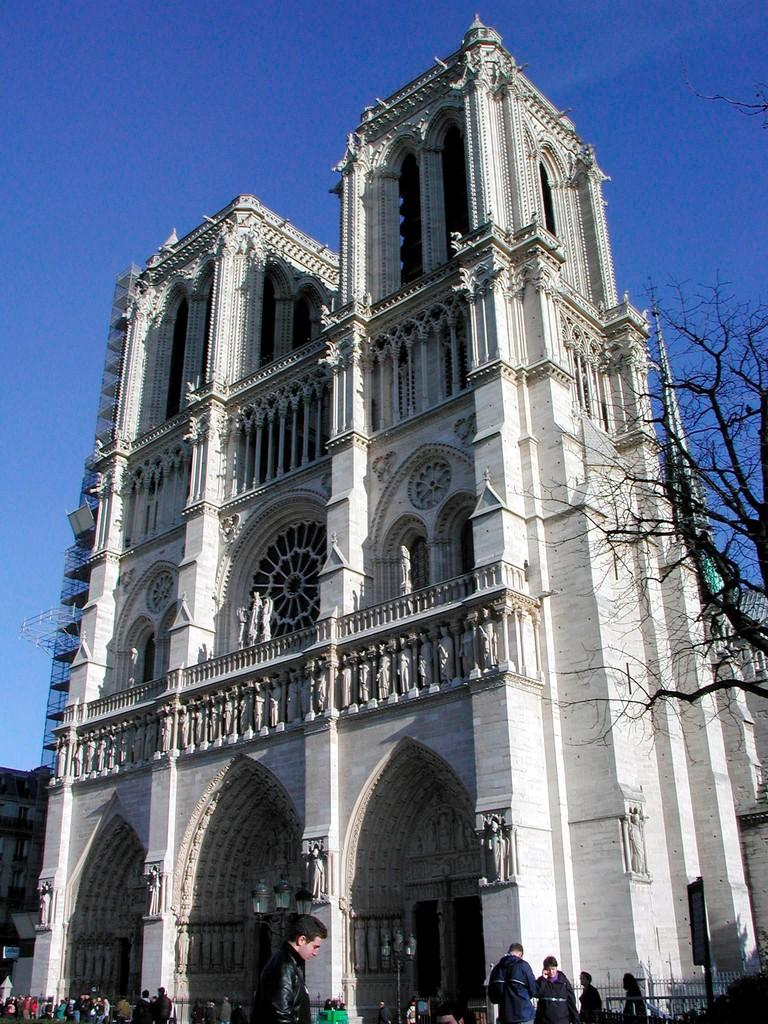What type of structures can be seen in the image? There are buildings in the image. What other objects are present in the image besides buildings? There are statues, a tree, people, light poles, a grille, and other objects in the image. What is the color of the sky in the background of the image? The sky is blue in the background of the image. Can you see a neck on any of the statues in the image? There is no mention of a neck or any specific details about the statues in the image, so it cannot be determined if a neck is present. What type of spring is visible in the image? There is no spring present in the image. 